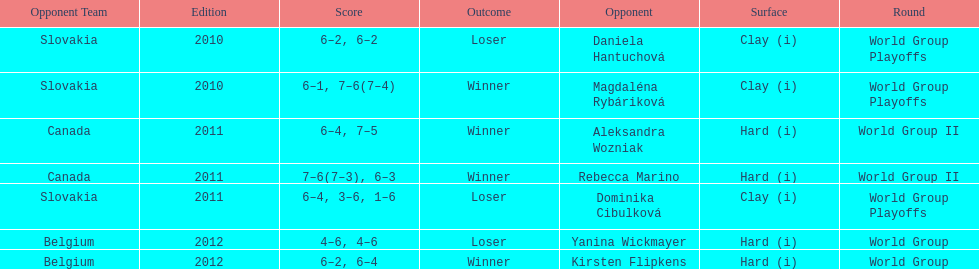Was the game versus canada later than the game versus belgium? No. 